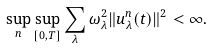Convert formula to latex. <formula><loc_0><loc_0><loc_500><loc_500>\sup _ { n } \sup _ { [ 0 , T ] } \sum _ { \lambda } \omega _ { \lambda } ^ { 2 } \| u _ { \lambda } ^ { n } ( t ) \| ^ { 2 } < \infty .</formula> 